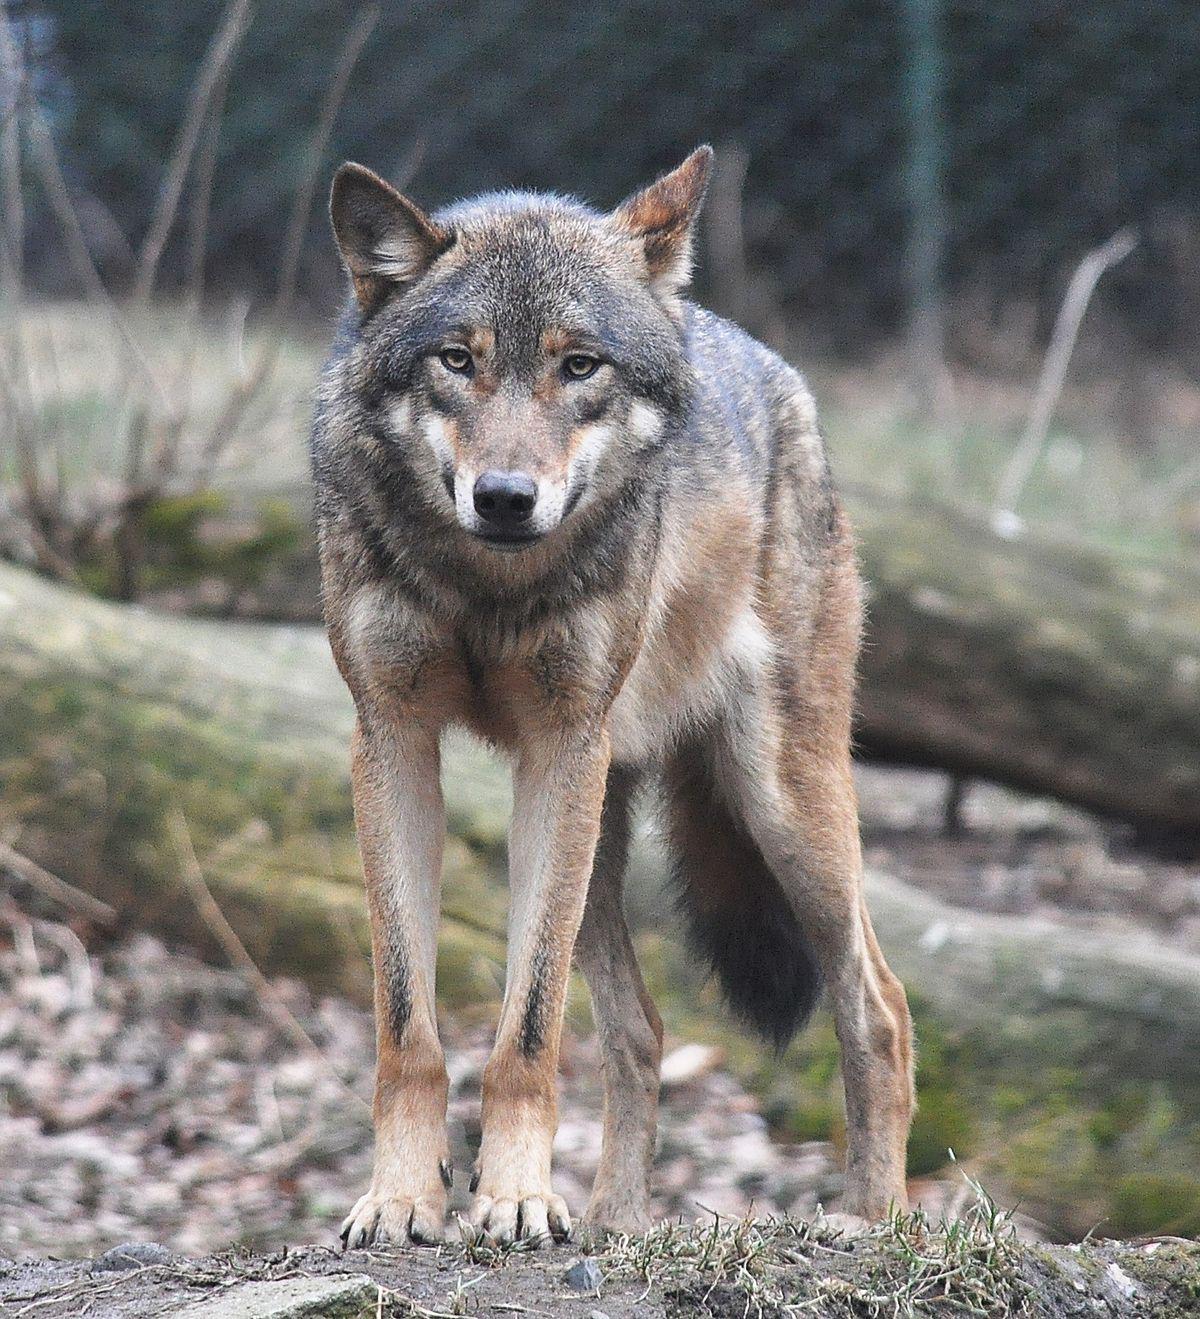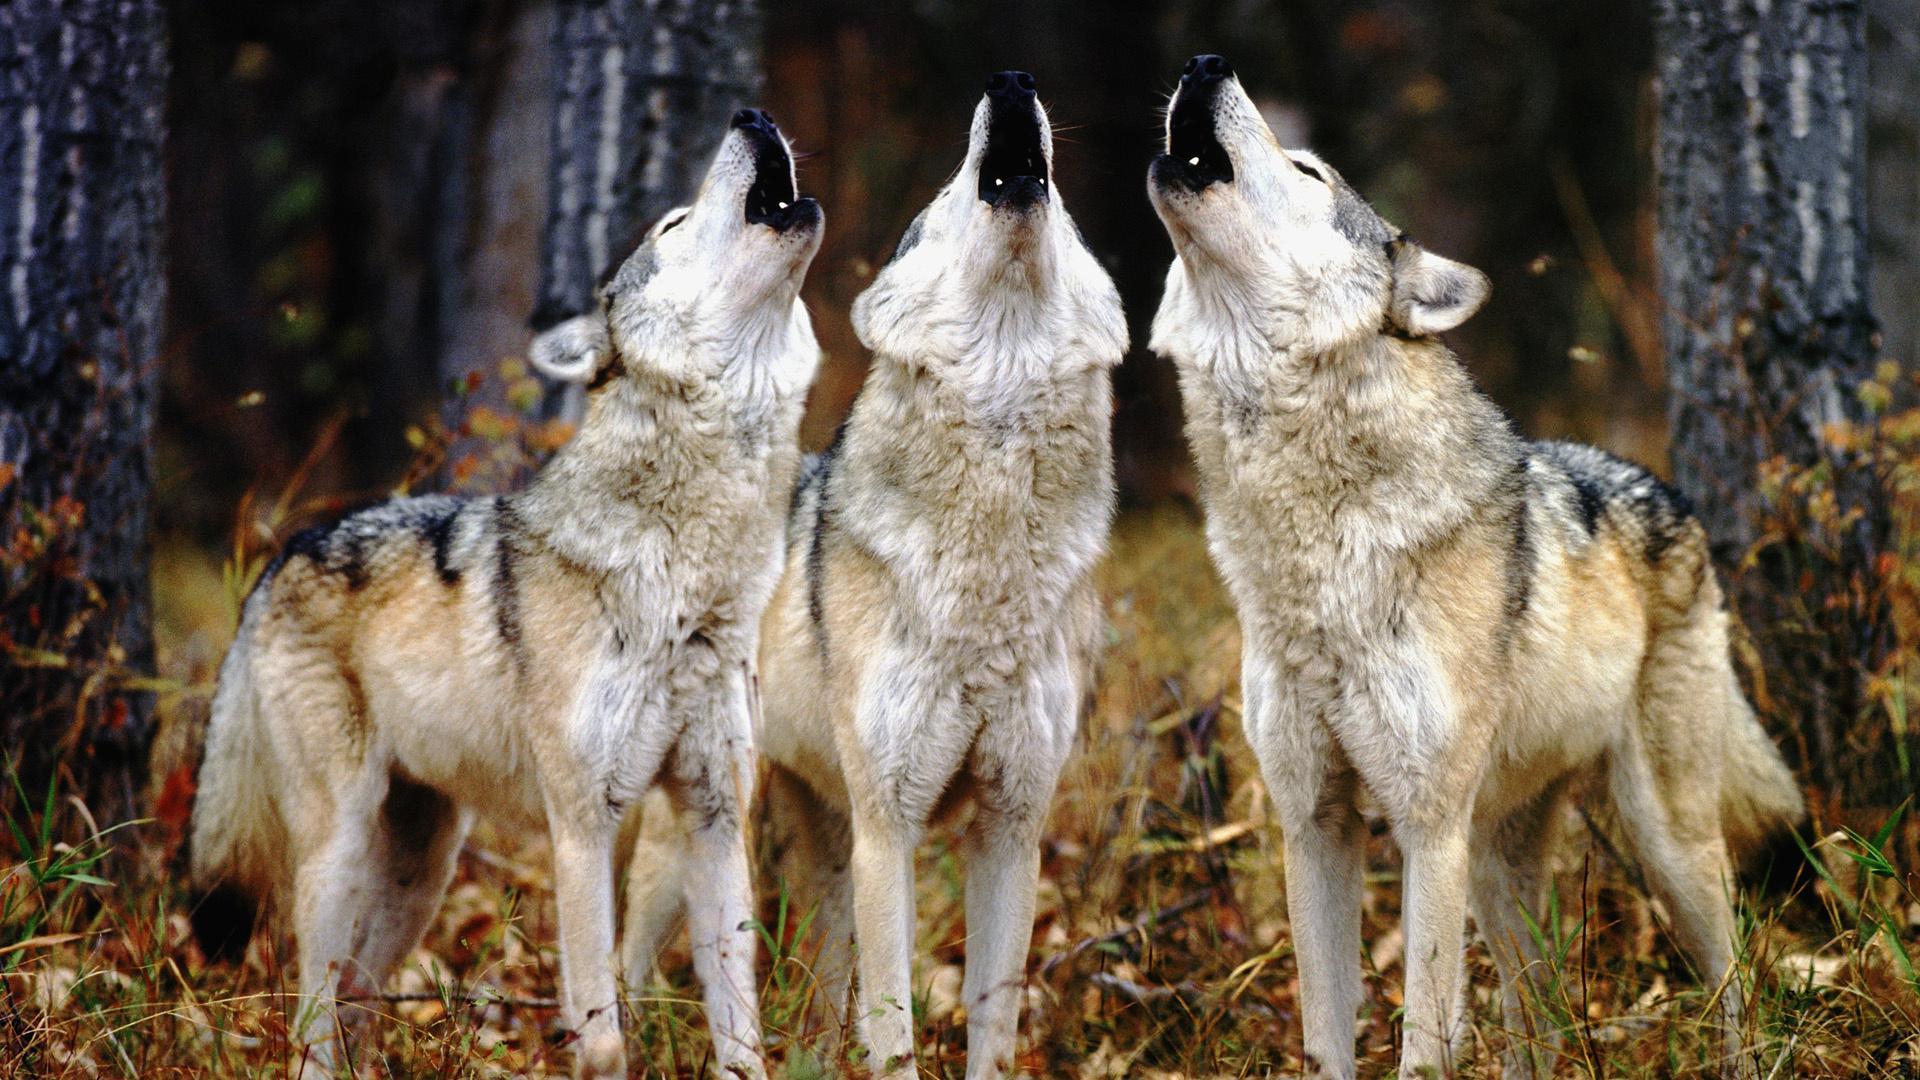The first image is the image on the left, the second image is the image on the right. Assess this claim about the two images: "There is no more than one wolf in the right image.". Correct or not? Answer yes or no. No. The first image is the image on the left, the second image is the image on the right. Assess this claim about the two images: "At least one wolf is standing in front of trees with its head raised in a howling pose.". Correct or not? Answer yes or no. Yes. 